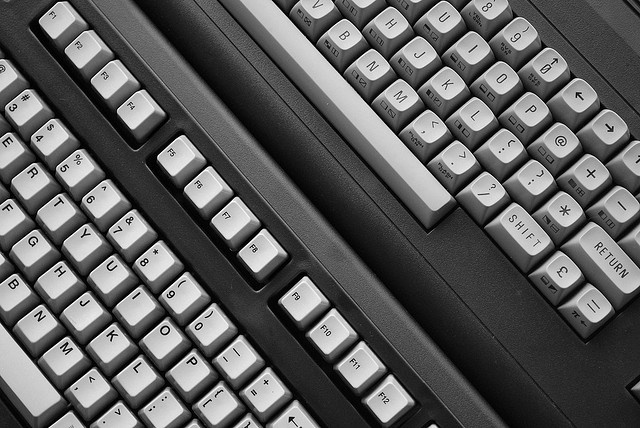Describe the objects in this image and their specific colors. I can see keyboard in black, gray, lightgray, and darkgray tones and keyboard in black, gray, lightgray, and darkgray tones in this image. 